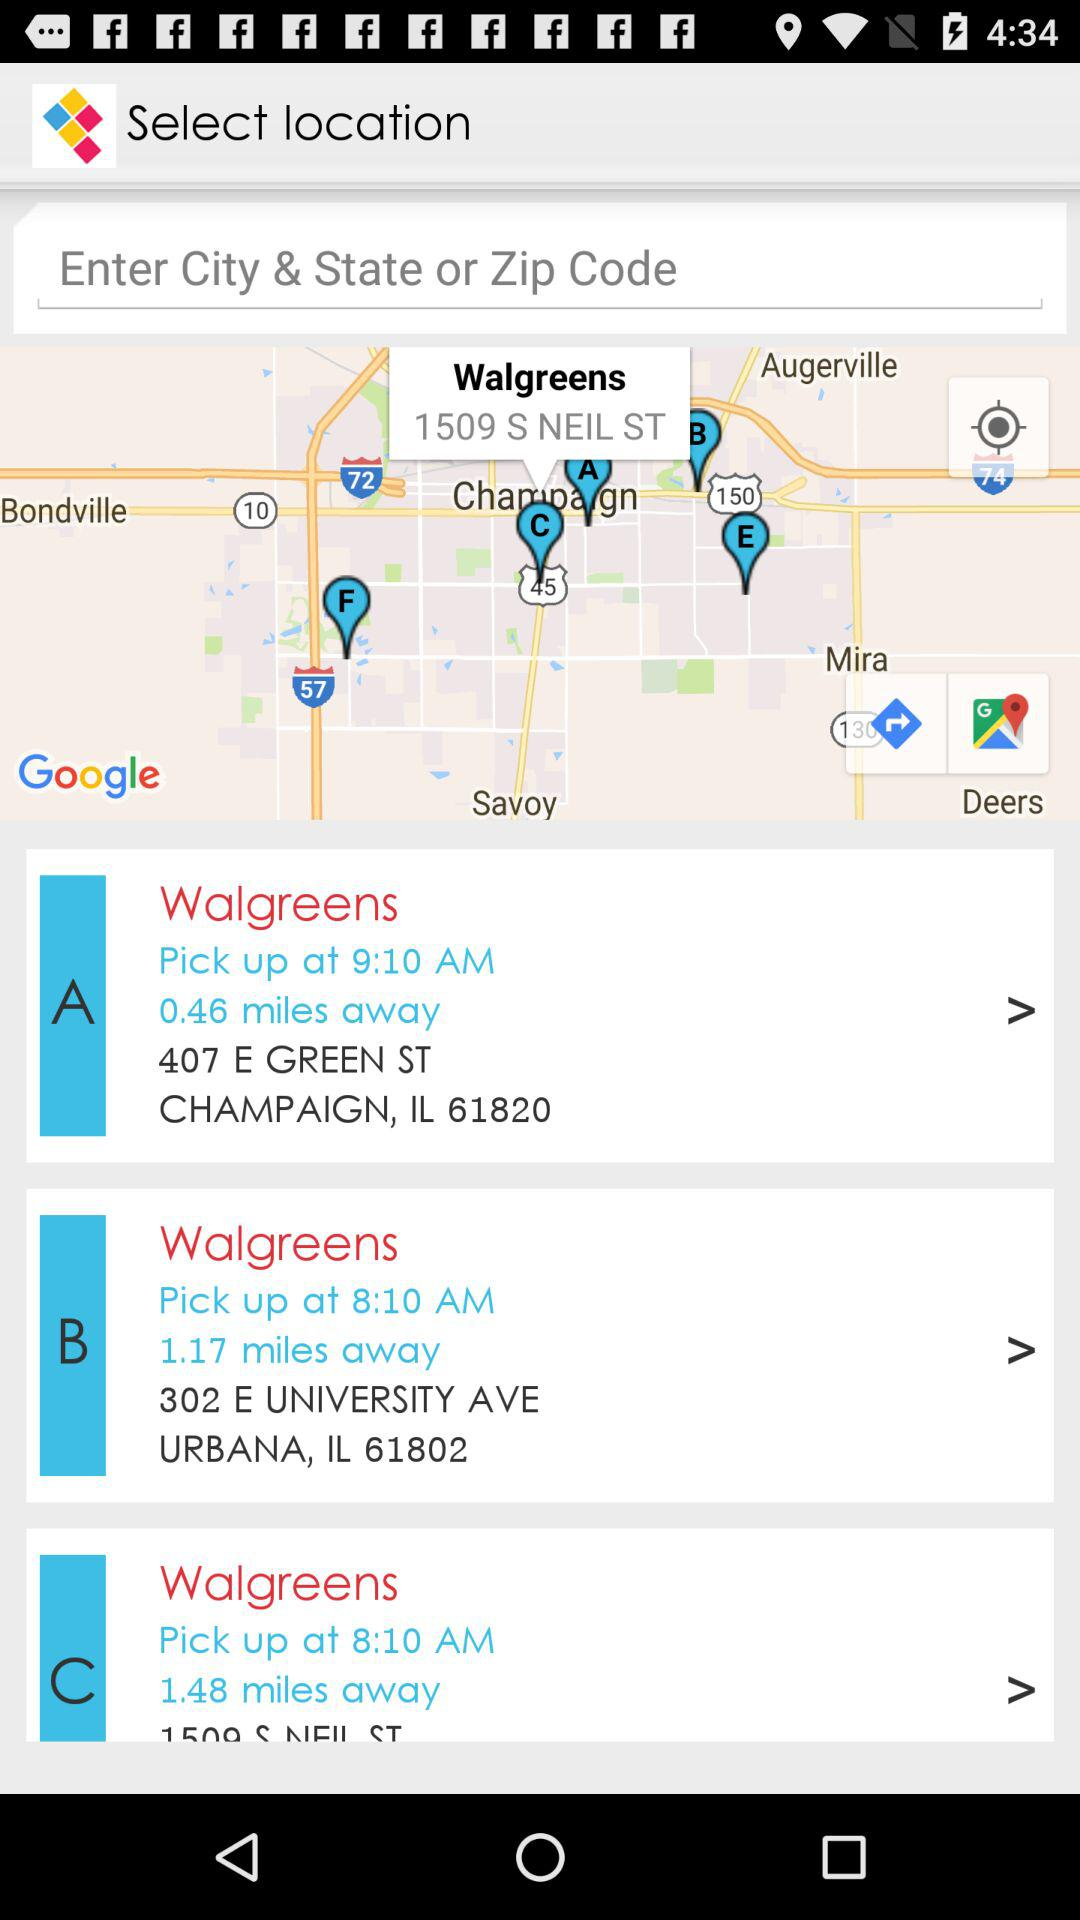What is the address of Walgreens at C?
When the provided information is insufficient, respond with <no answer>. <no answer> 